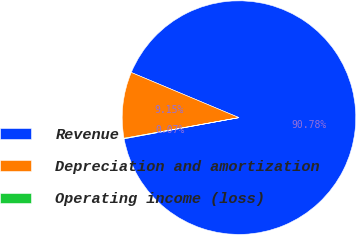<chart> <loc_0><loc_0><loc_500><loc_500><pie_chart><fcel>Revenue<fcel>Depreciation and amortization<fcel>Operating income (loss)<nl><fcel>90.78%<fcel>9.15%<fcel>0.07%<nl></chart> 